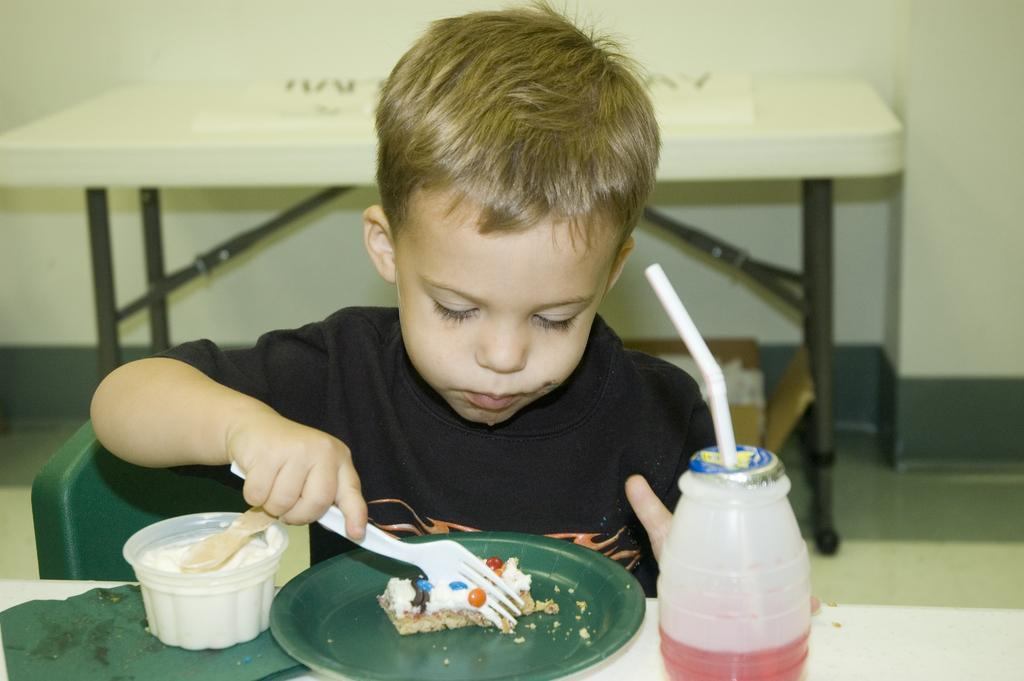Who is the main subject in the image? There is a boy in the image. What is the boy doing in the image? The boy is having food. What can be seen on the table in the image? There are food products on a table. Where is the table located in relation to the boy? There is a table behind the person. What type of farm animals can be seen in the image? There are no farm animals present in the image. Is the boy wearing a collar in the image? There is no mention of a collar in the image, and the boy is not wearing one. 